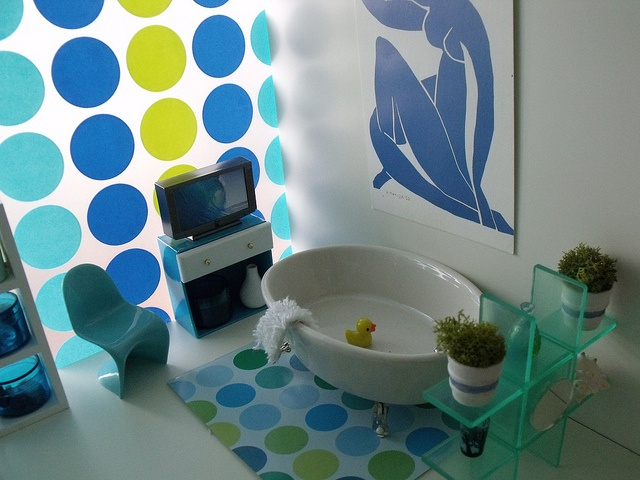Describe the objects in this image and their specific colors. I can see sink in lightblue and gray tones, chair in lightblue, teal, and black tones, tv in lightblue, black, darkblue, gray, and blue tones, potted plant in lightblue, black, teal, and darkgreen tones, and potted plant in lightblue, black, gray, darkgreen, and darkgray tones in this image. 